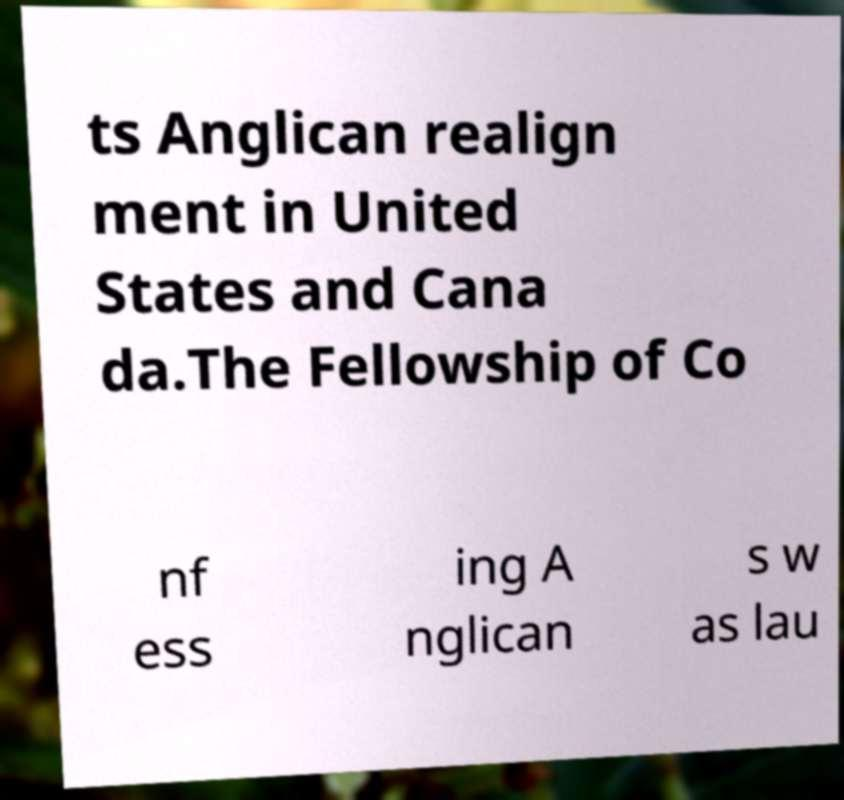What messages or text are displayed in this image? I need them in a readable, typed format. ts Anglican realign ment in United States and Cana da.The Fellowship of Co nf ess ing A nglican s w as lau 